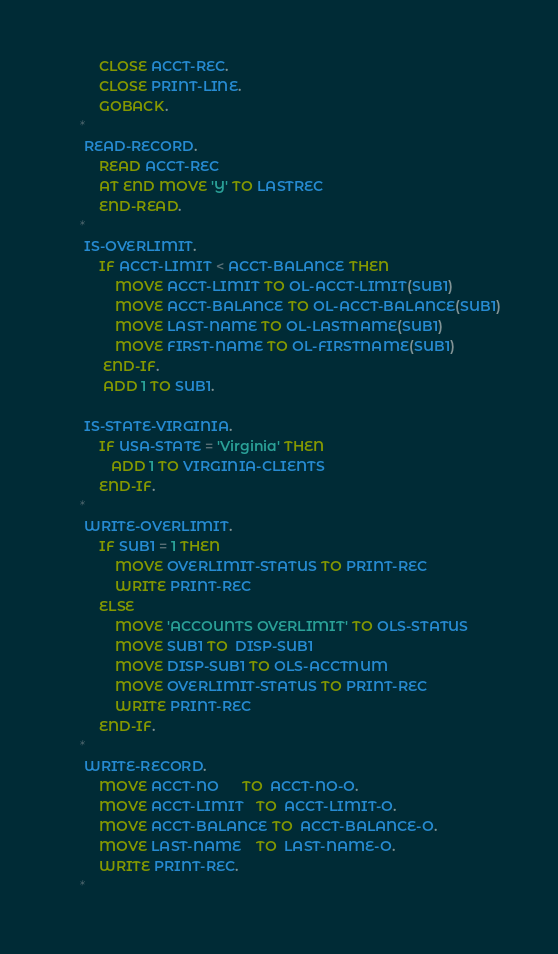<code> <loc_0><loc_0><loc_500><loc_500><_COBOL_>           CLOSE ACCT-REC.
           CLOSE PRINT-LINE.
           GOBACK.
      *
       READ-RECORD.
           READ ACCT-REC
           AT END MOVE 'Y' TO LASTREC
           END-READ.
      *
       IS-OVERLIMIT.
           IF ACCT-LIMIT < ACCT-BALANCE THEN
               MOVE ACCT-LIMIT TO OL-ACCT-LIMIT(SUB1)
               MOVE ACCT-BALANCE TO OL-ACCT-BALANCE(SUB1)
               MOVE LAST-NAME TO OL-LASTNAME(SUB1)
               MOVE FIRST-NAME TO OL-FIRSTNAME(SUB1)
            END-IF.
            ADD 1 TO SUB1.

       IS-STATE-VIRGINIA.
           IF USA-STATE = 'Virginia' THEN
              ADD 1 TO VIRGINIA-CLIENTS
           END-IF.
      *
       WRITE-OVERLIMIT.
           IF SUB1 = 1 THEN
               MOVE OVERLIMIT-STATUS TO PRINT-REC
               WRITE PRINT-REC
           ELSE
               MOVE 'ACCOUNTS OVERLIMIT' TO OLS-STATUS
               MOVE SUB1 TO  DISP-SUB1
               MOVE DISP-SUB1 TO OLS-ACCTNUM
               MOVE OVERLIMIT-STATUS TO PRINT-REC
               WRITE PRINT-REC
           END-IF.
      *
       WRITE-RECORD.
           MOVE ACCT-NO      TO  ACCT-NO-O.
           MOVE ACCT-LIMIT   TO  ACCT-LIMIT-O.
           MOVE ACCT-BALANCE TO  ACCT-BALANCE-O.
           MOVE LAST-NAME    TO  LAST-NAME-O.
           WRITE PRINT-REC.
      *
</code> 